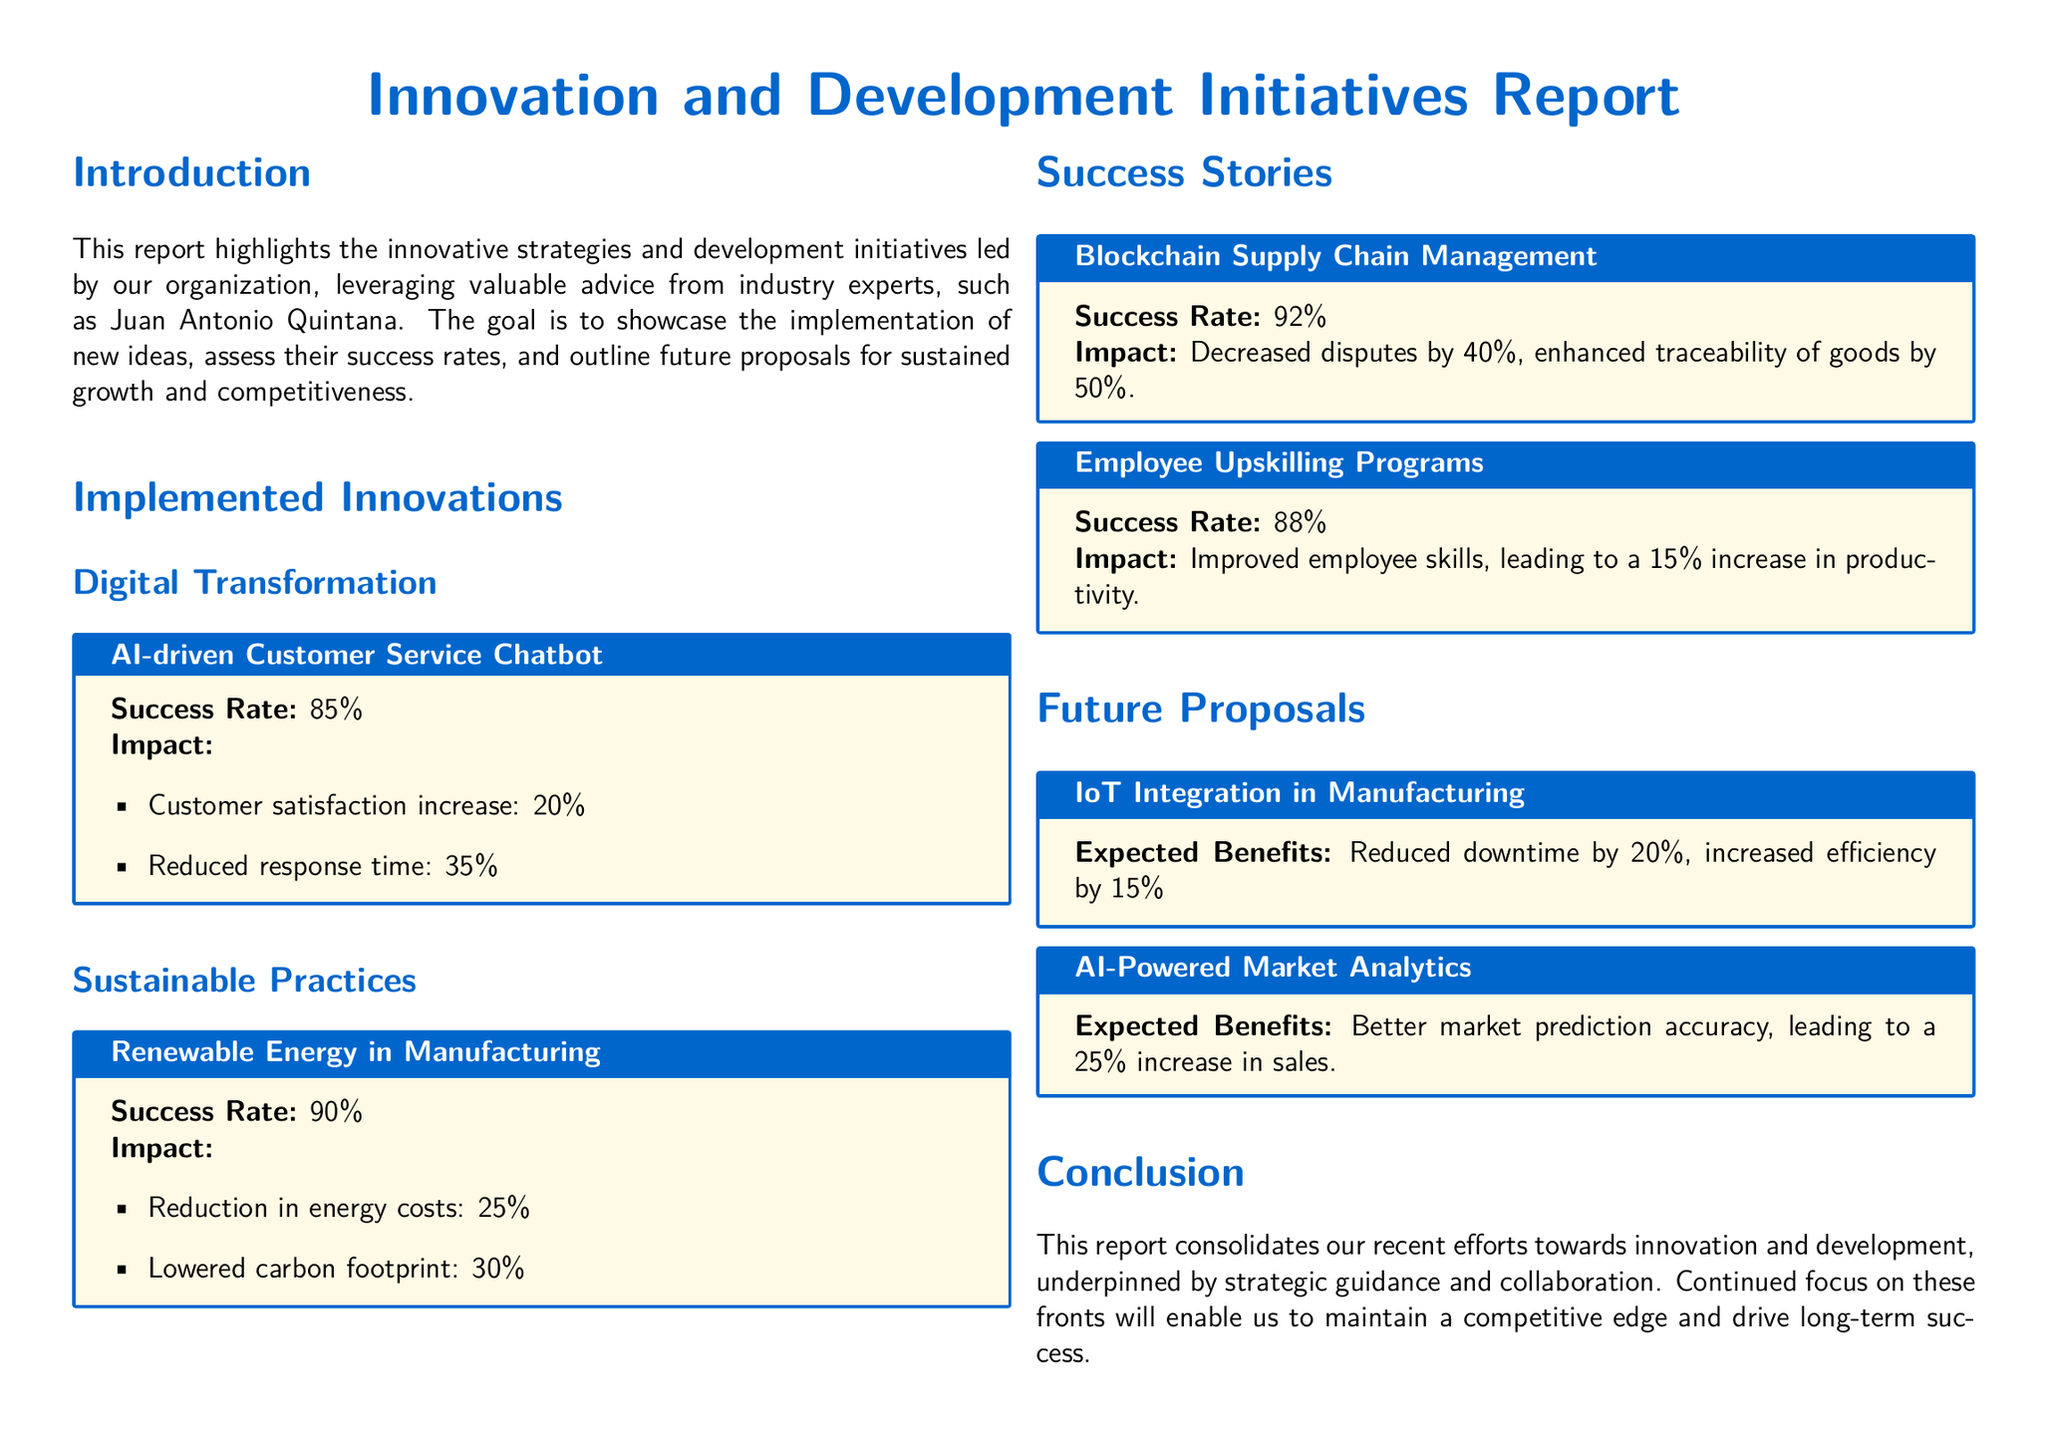What is the success rate of the AI-driven Customer Service Chatbot? The success rate is specifically stated in the document as 85%.
Answer: 85% What impact did renewable energy have on energy costs? The document mentions a reduction in energy costs by 25%.
Answer: 25% What was the increase in productivity due to Employee Upskilling Programs? The report specifies a 15% increase in productivity linked to these programs.
Answer: 15% What technology is proposed for integration in manufacturing? The document mentions IoT Integration as a future proposal for manufacturing.
Answer: IoT Integration What is the expected benefit of AI-Powered Market Analytics? The expected benefit stated in the document is a 25% increase in sales.
Answer: 25% Which initiative had a success rate of 92%? The initiative with a 92% success rate is Blockchain Supply Chain Management, as per the document.
Answer: Blockchain Supply Chain Management What is the expected reduction in downtime from IoT Integration? The document indicates a 20% reduction in downtime is expected from IoT Integration.
Answer: 20% What impact did the blockchain initiative have on disputes? The impact noted is a decrease in disputes by 40%.
Answer: 40% What color is used for the main title in the document? The color specified for the main title is RGB(0,102,204) in the report.
Answer: RGB(0,102,204) What section follows "Implemented Innovations"? The section that follows is titled "Success Stories."
Answer: Success Stories 